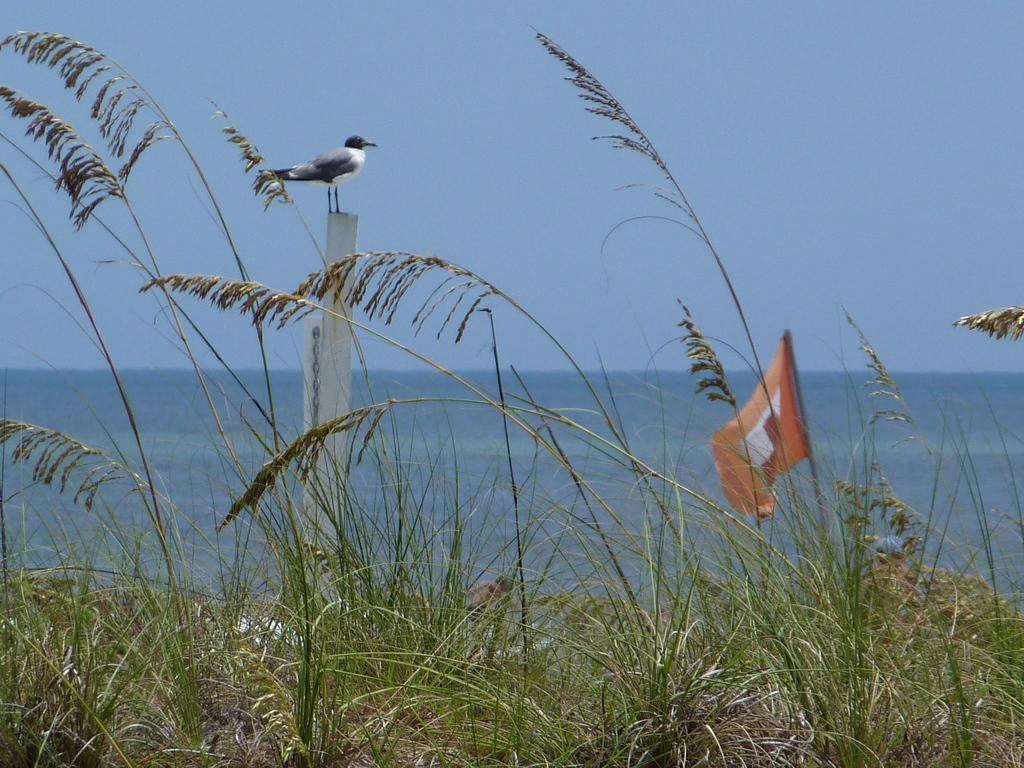In one or two sentences, can you explain what this image depicts? In this picture we can see the grass, bird is on the pole, behind we can see full of water. 